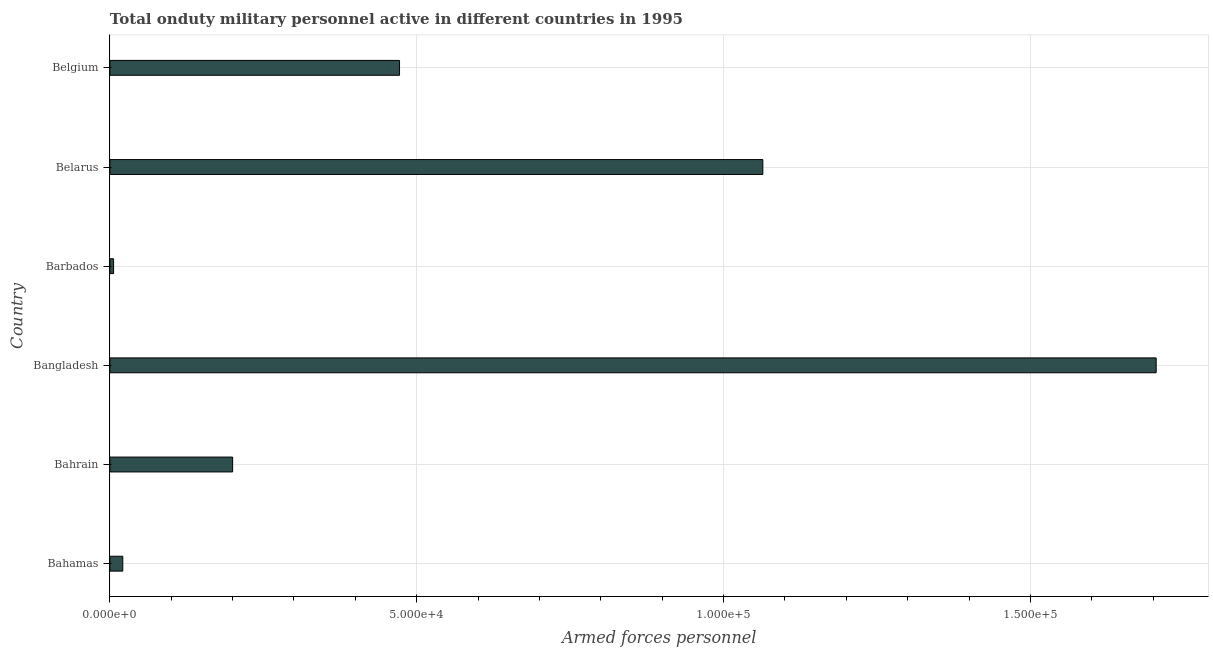What is the title of the graph?
Provide a succinct answer. Total onduty military personnel active in different countries in 1995. What is the label or title of the X-axis?
Your answer should be very brief. Armed forces personnel. What is the label or title of the Y-axis?
Your answer should be compact. Country. What is the number of armed forces personnel in Belarus?
Offer a very short reply. 1.06e+05. Across all countries, what is the maximum number of armed forces personnel?
Make the answer very short. 1.70e+05. Across all countries, what is the minimum number of armed forces personnel?
Your response must be concise. 600. In which country was the number of armed forces personnel minimum?
Give a very brief answer. Barbados. What is the sum of the number of armed forces personnel?
Your answer should be compact. 3.47e+05. What is the difference between the number of armed forces personnel in Bahamas and Barbados?
Offer a terse response. 1500. What is the average number of armed forces personnel per country?
Provide a short and direct response. 5.78e+04. What is the median number of armed forces personnel?
Provide a short and direct response. 3.36e+04. In how many countries, is the number of armed forces personnel greater than 160000 ?
Give a very brief answer. 1. What is the ratio of the number of armed forces personnel in Bahamas to that in Bangladesh?
Provide a succinct answer. 0.01. What is the difference between the highest and the second highest number of armed forces personnel?
Keep it short and to the point. 6.41e+04. What is the difference between the highest and the lowest number of armed forces personnel?
Your response must be concise. 1.70e+05. In how many countries, is the number of armed forces personnel greater than the average number of armed forces personnel taken over all countries?
Provide a short and direct response. 2. Are all the bars in the graph horizontal?
Offer a terse response. Yes. How many countries are there in the graph?
Provide a succinct answer. 6. What is the Armed forces personnel of Bahamas?
Offer a terse response. 2100. What is the Armed forces personnel in Bahrain?
Your response must be concise. 2.00e+04. What is the Armed forces personnel of Bangladesh?
Your answer should be compact. 1.70e+05. What is the Armed forces personnel in Barbados?
Provide a succinct answer. 600. What is the Armed forces personnel in Belarus?
Offer a very short reply. 1.06e+05. What is the Armed forces personnel of Belgium?
Your answer should be very brief. 4.72e+04. What is the difference between the Armed forces personnel in Bahamas and Bahrain?
Give a very brief answer. -1.79e+04. What is the difference between the Armed forces personnel in Bahamas and Bangladesh?
Offer a terse response. -1.68e+05. What is the difference between the Armed forces personnel in Bahamas and Barbados?
Your answer should be compact. 1500. What is the difference between the Armed forces personnel in Bahamas and Belarus?
Keep it short and to the point. -1.04e+05. What is the difference between the Armed forces personnel in Bahamas and Belgium?
Provide a succinct answer. -4.51e+04. What is the difference between the Armed forces personnel in Bahrain and Bangladesh?
Offer a very short reply. -1.50e+05. What is the difference between the Armed forces personnel in Bahrain and Barbados?
Offer a terse response. 1.94e+04. What is the difference between the Armed forces personnel in Bahrain and Belarus?
Offer a very short reply. -8.64e+04. What is the difference between the Armed forces personnel in Bahrain and Belgium?
Provide a succinct answer. -2.72e+04. What is the difference between the Armed forces personnel in Bangladesh and Barbados?
Give a very brief answer. 1.70e+05. What is the difference between the Armed forces personnel in Bangladesh and Belarus?
Give a very brief answer. 6.41e+04. What is the difference between the Armed forces personnel in Bangladesh and Belgium?
Make the answer very short. 1.23e+05. What is the difference between the Armed forces personnel in Barbados and Belarus?
Offer a terse response. -1.06e+05. What is the difference between the Armed forces personnel in Barbados and Belgium?
Make the answer very short. -4.66e+04. What is the difference between the Armed forces personnel in Belarus and Belgium?
Provide a short and direct response. 5.92e+04. What is the ratio of the Armed forces personnel in Bahamas to that in Bahrain?
Your answer should be compact. 0.1. What is the ratio of the Armed forces personnel in Bahamas to that in Bangladesh?
Make the answer very short. 0.01. What is the ratio of the Armed forces personnel in Bahamas to that in Belarus?
Provide a short and direct response. 0.02. What is the ratio of the Armed forces personnel in Bahamas to that in Belgium?
Your response must be concise. 0.04. What is the ratio of the Armed forces personnel in Bahrain to that in Bangladesh?
Keep it short and to the point. 0.12. What is the ratio of the Armed forces personnel in Bahrain to that in Barbados?
Offer a very short reply. 33.33. What is the ratio of the Armed forces personnel in Bahrain to that in Belarus?
Make the answer very short. 0.19. What is the ratio of the Armed forces personnel in Bahrain to that in Belgium?
Offer a very short reply. 0.42. What is the ratio of the Armed forces personnel in Bangladesh to that in Barbados?
Make the answer very short. 284.17. What is the ratio of the Armed forces personnel in Bangladesh to that in Belarus?
Provide a succinct answer. 1.6. What is the ratio of the Armed forces personnel in Bangladesh to that in Belgium?
Offer a terse response. 3.61. What is the ratio of the Armed forces personnel in Barbados to that in Belarus?
Give a very brief answer. 0.01. What is the ratio of the Armed forces personnel in Barbados to that in Belgium?
Offer a terse response. 0.01. What is the ratio of the Armed forces personnel in Belarus to that in Belgium?
Provide a succinct answer. 2.25. 